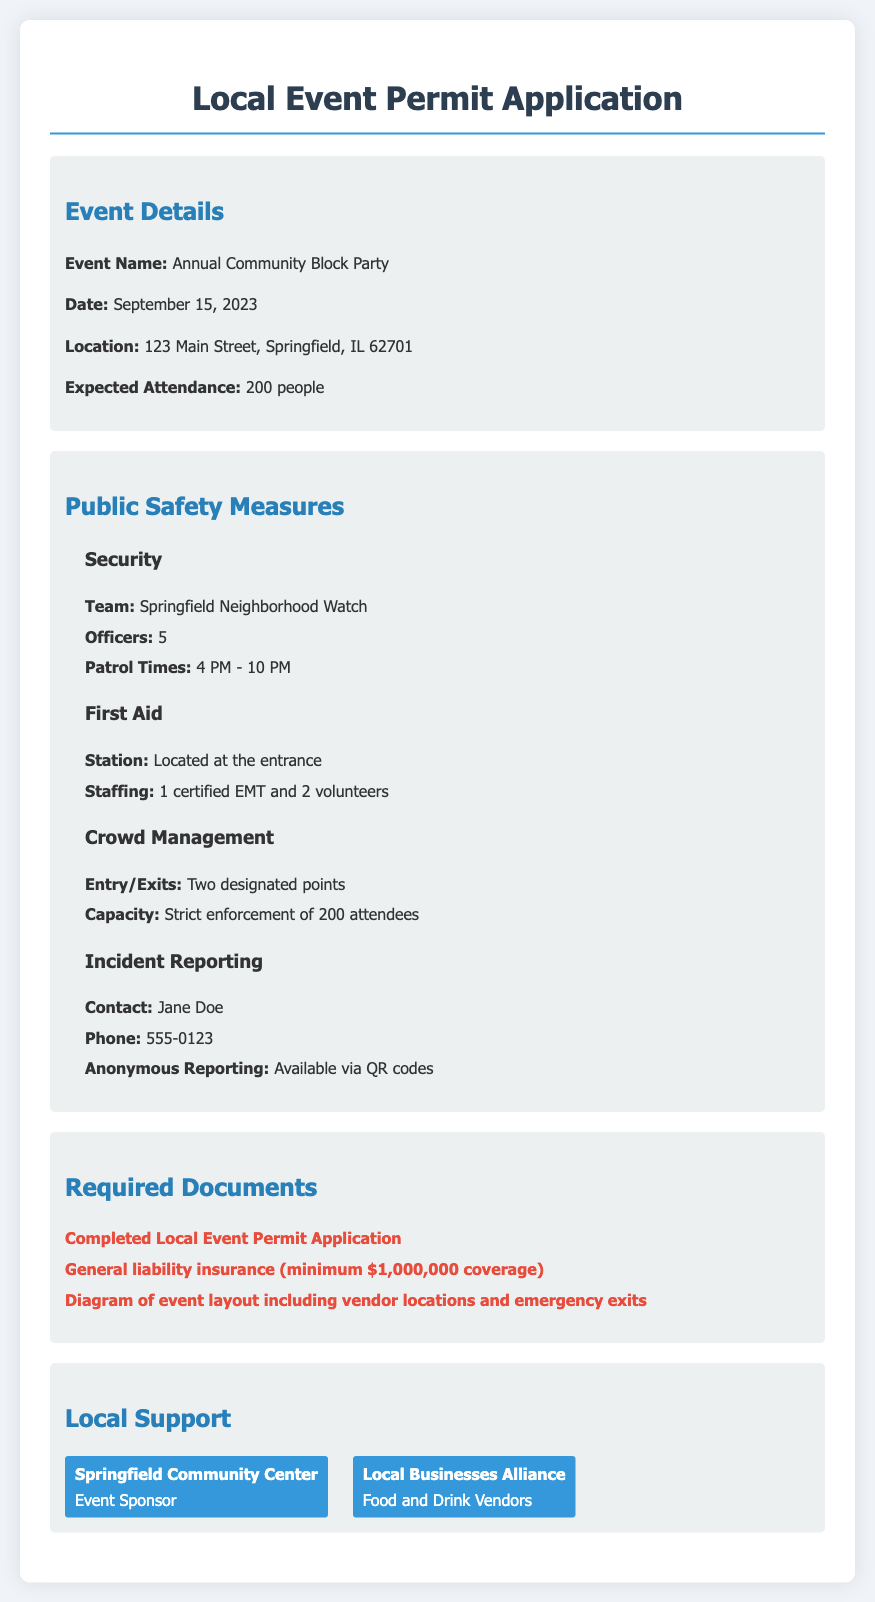what is the event name? The event name is explicitly stated at the beginning of the event details section in the document.
Answer: Annual Community Block Party when is the event scheduled to take place? The date is clearly mentioned in the event details section of the document.
Answer: September 15, 2023 where will the event be held? The location is provided in the event details section of the document.
Answer: 123 Main Street, Springfield, IL 62701 how many people are expected to attend? The expected attendance is mentioned in the event details section.
Answer: 200 people who is responsible for security during the event? The name is listed in the public safety measures section under Security.
Answer: Springfield Neighborhood Watch how many officers will patrol the event? The number of officers is indicated in the Security subsection of public safety measures.
Answer: 5 what time will the patrol begin? The patrol times are outlined in the Security subsection.
Answer: 4 PM what document ensures liability coverage for the event? The required document for liability coverage is detailed in the Required Documents section.
Answer: General liability insurance (minimum $1,000,000 coverage) who should be contacted for incident reporting? The contact person is specified in the Incident Reporting subsection of public safety measures.
Answer: Jane Doe 